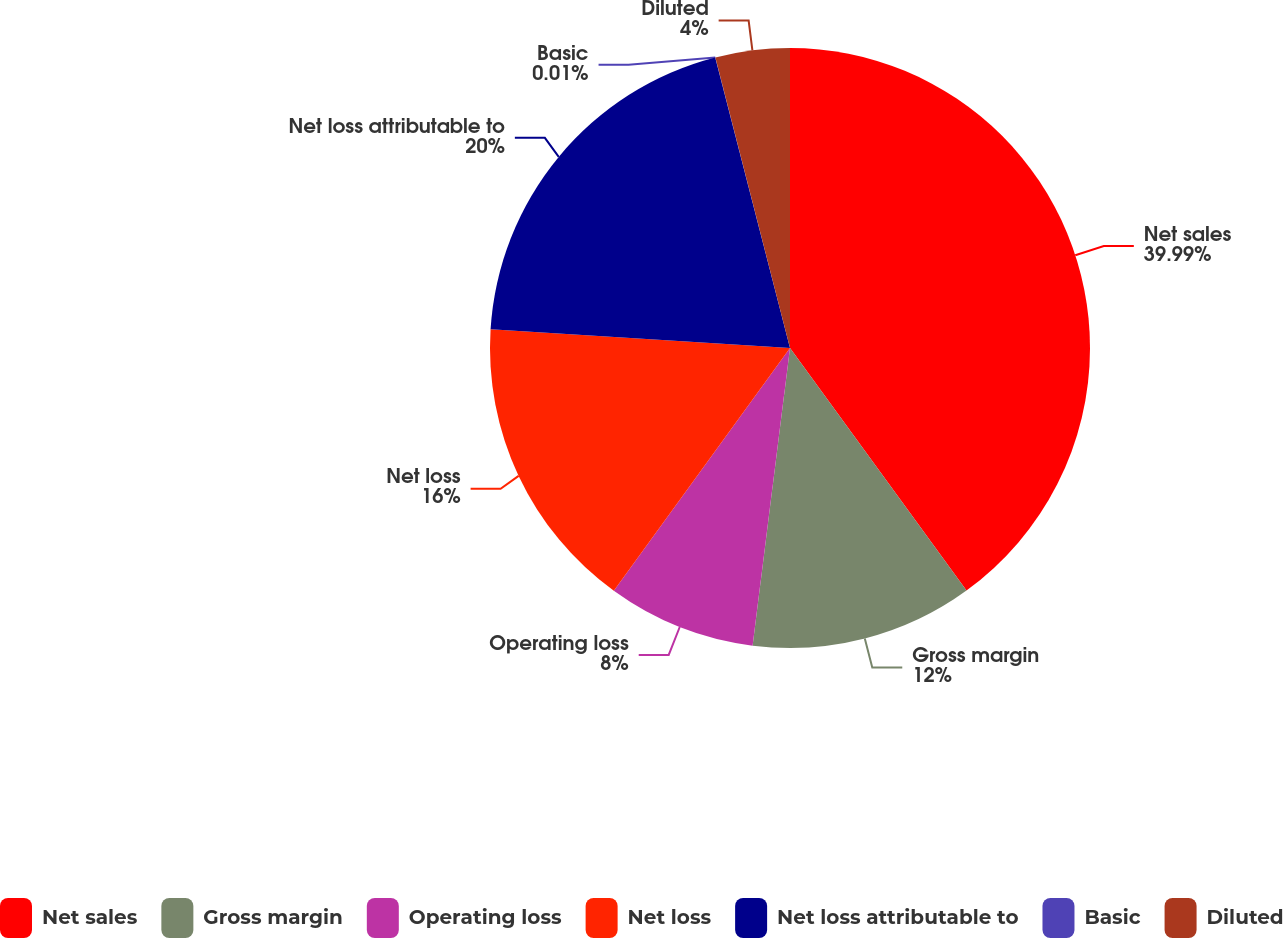Convert chart to OTSL. <chart><loc_0><loc_0><loc_500><loc_500><pie_chart><fcel>Net sales<fcel>Gross margin<fcel>Operating loss<fcel>Net loss<fcel>Net loss attributable to<fcel>Basic<fcel>Diluted<nl><fcel>39.99%<fcel>12.0%<fcel>8.0%<fcel>16.0%<fcel>20.0%<fcel>0.01%<fcel>4.0%<nl></chart> 